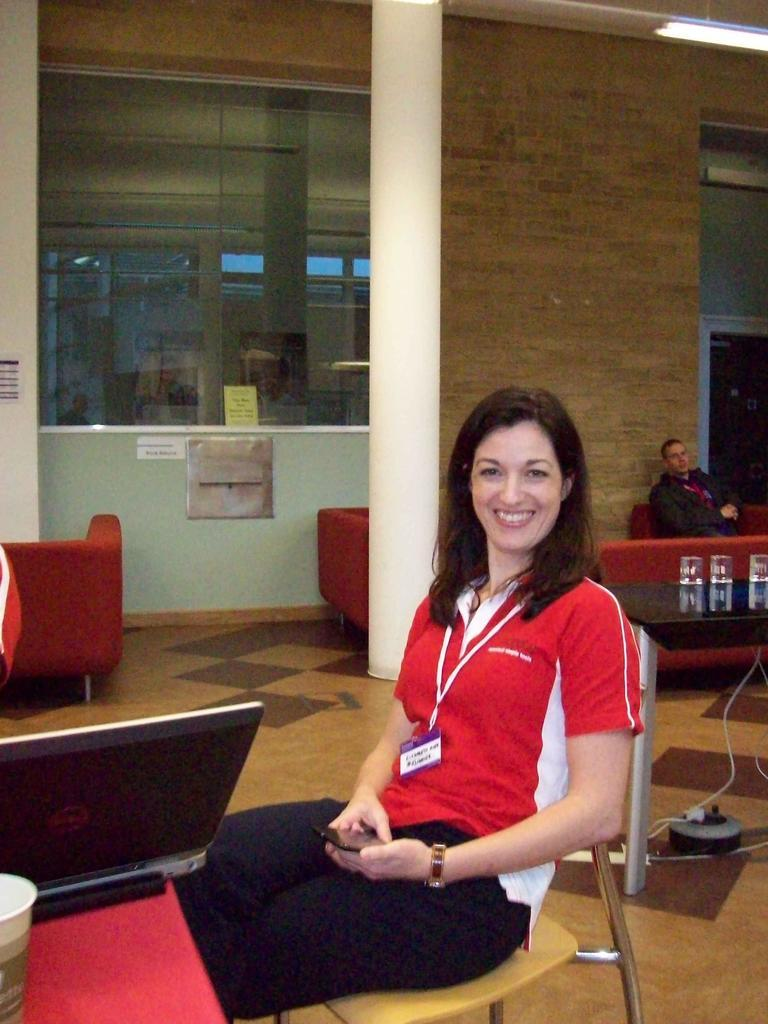Who is the main subject in the image? There is a woman in the image. What is the woman doing in the image? The woman is sitting in a chair. What is the woman wearing in the image? The woman is wearing a red T-shirt. What is the woman's facial expression in the image? The woman is smiling. Can you describe the background of the image? There is a wall in the background. Is there anyone else in the image besides the woman? Yes, there is a man behind the woman. Can you see any lakes or bodies of water in the image? No, there are no lakes or bodies of water visible in the image. Are there any flies present in the image? No, there are no flies present in the image. 